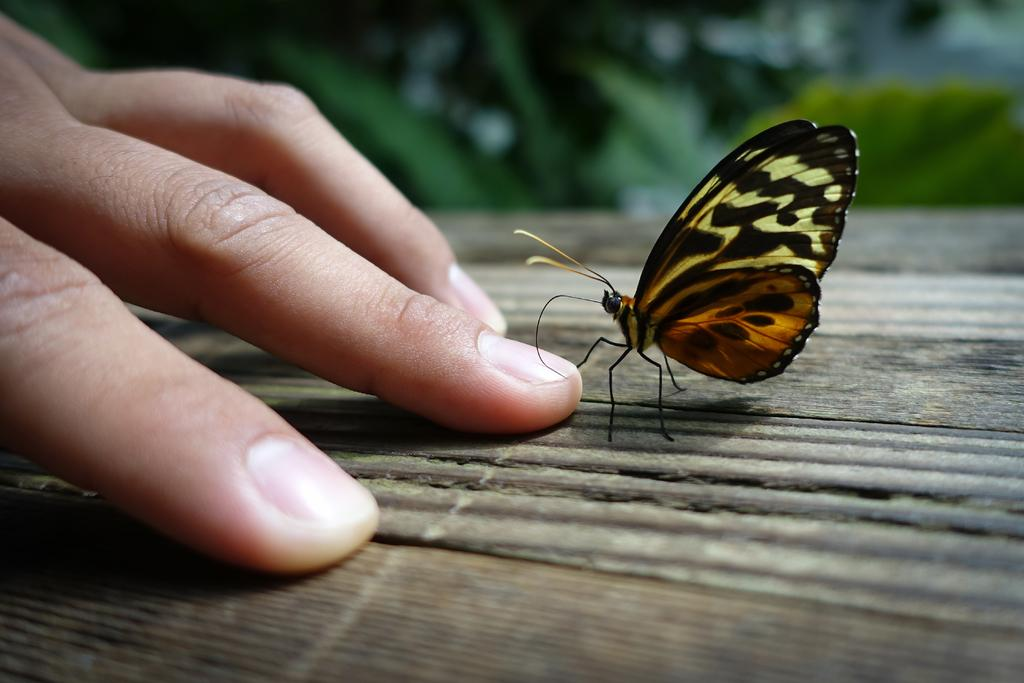What type of creature can be seen in the image? There is a butterfly in the image. What part of a person is visible in the image? Human fingers are on an object in the image. Can you describe the background of the image? The background of the image is blurred. What type of muscle is being used to apply the glue in the image? There is no glue present in the image, and therefore no muscles are being used to apply it. 